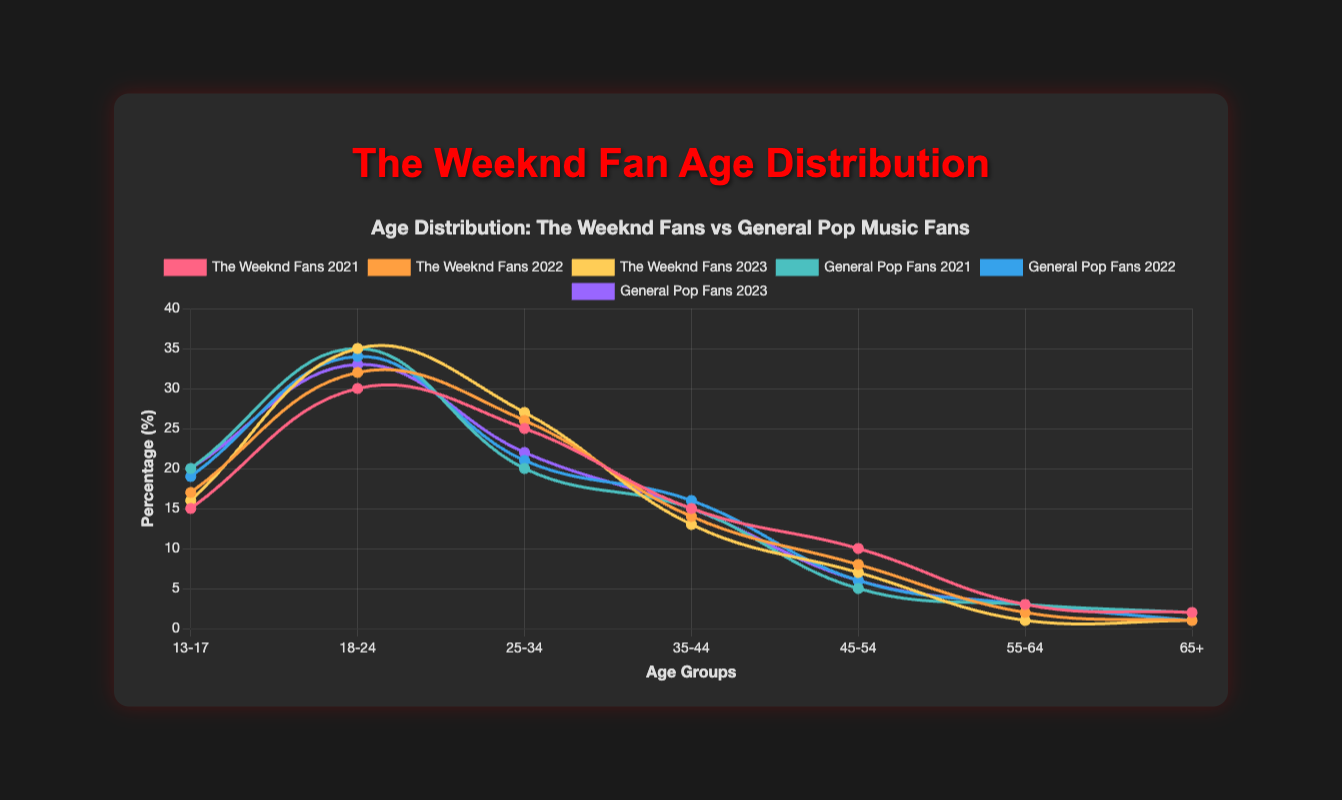What age group makes up the largest percentage of The Weeknd's fans in 2023? The highest data point for The Weeknd's fans in 2023 is 35% which belongs to the 18-24 age group.
Answer: 18-24 How does the percentage of 13-17 year-olds who are fans of The Weeknd in 2023 compare to the general pop music fans in the same year? The percentage of 13-17 year-olds who are The Weeknd's fans in 2023 is 16%, while the percentage for general pop music fans in the same year is 20%.
Answer: Less Which age group shows the largest decrease in The Weeknd's fans from 2021 to 2023? To calculate the largest decrease, subtract the 2023 values from the 2021 values: 13-17 (15 to 16 -> -1), 18-24 (30 to 35 -> -5), 25-34 (25 to 27 -> -2), 35-44 (15 to 13 -> 2), 45-54 (10 to 7 -> -3), 55-64 (3 to 1 -> -2), 65+ (2 to 1 -> -1). The largest decrease is in the 45-54 age group with a drop of -3.
Answer: 45-54 What is the combined percentage of The Weeknd's fans aged 25-34 and 35-44 in 2021? Adding the 2021 data for these age groups: 25-34 (25) + 35-44 (15) = 40%.
Answer: 40% For which year do The Weeknd's fans aged 18-24 have the smallest share, and what percentage is it? Looking at the data for The Weeknd's fans aged 18-24 over the years: 2021 (30%), 2022 (32%), and 2023 (35%). The smallest share is in 2021 with 30%.
Answer: 2021, 30% In the year 2022, which age group saw a higher percentage of fans for The Weeknd compared to general pop music fans? Comparing the 2022 data for The Weeknd's fans and general pop music fans by age group: 13-17 (17 vs 19), 18-24 (32 vs 34), 25-34 (26 vs 21), 35-44 (14 vs 16), 45-54 (8 vs 6), 55-64 (2 vs 3), 65+ (1 vs 1). Only the 25-34 age group (26% vs 21%) and 45-54 age group (8% vs 6%) are higher for The Weeknd's fans.
Answer: 25-34, 45-54 Across the three years, which age group generally has the smallest proportion of The Weeknd's fanbase? Reviewing the data across 2021 to 2023 for The Weeknd's fanbase by age group: 13-17 (15, 17, 16), 18-24 (30, 32, 35), 25-34 (25, 26, 27), 35-44 (15, 14, 13), 45-54 (10, 8, 7), 55-64 (3, 2, 1), 65+ (2, 1, 1). The 65+ age group consistently has the smallest proportion.
Answer: 65+ 